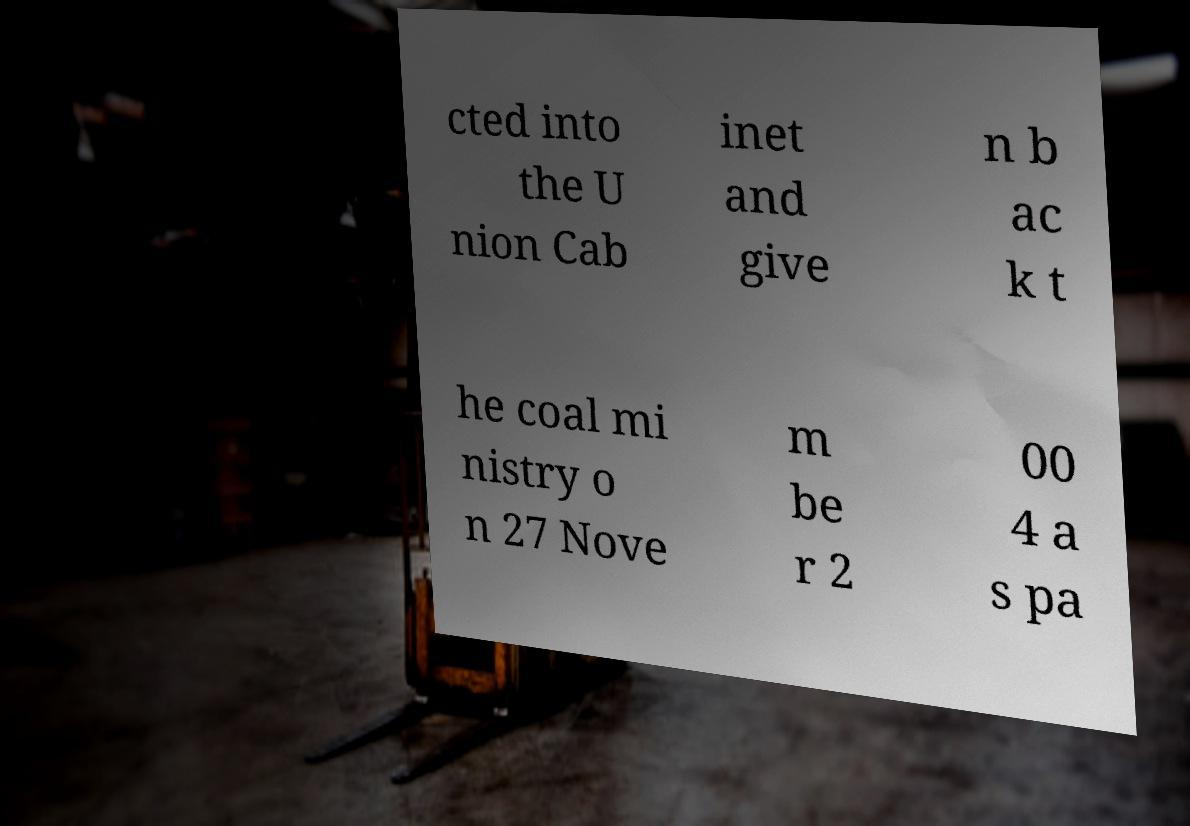I need the written content from this picture converted into text. Can you do that? cted into the U nion Cab inet and give n b ac k t he coal mi nistry o n 27 Nove m be r 2 00 4 a s pa 